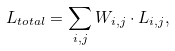Convert formula to latex. <formula><loc_0><loc_0><loc_500><loc_500>L _ { t o t a l } = \sum _ { i , j } W _ { i , j } \cdot L _ { i , j } ,</formula> 